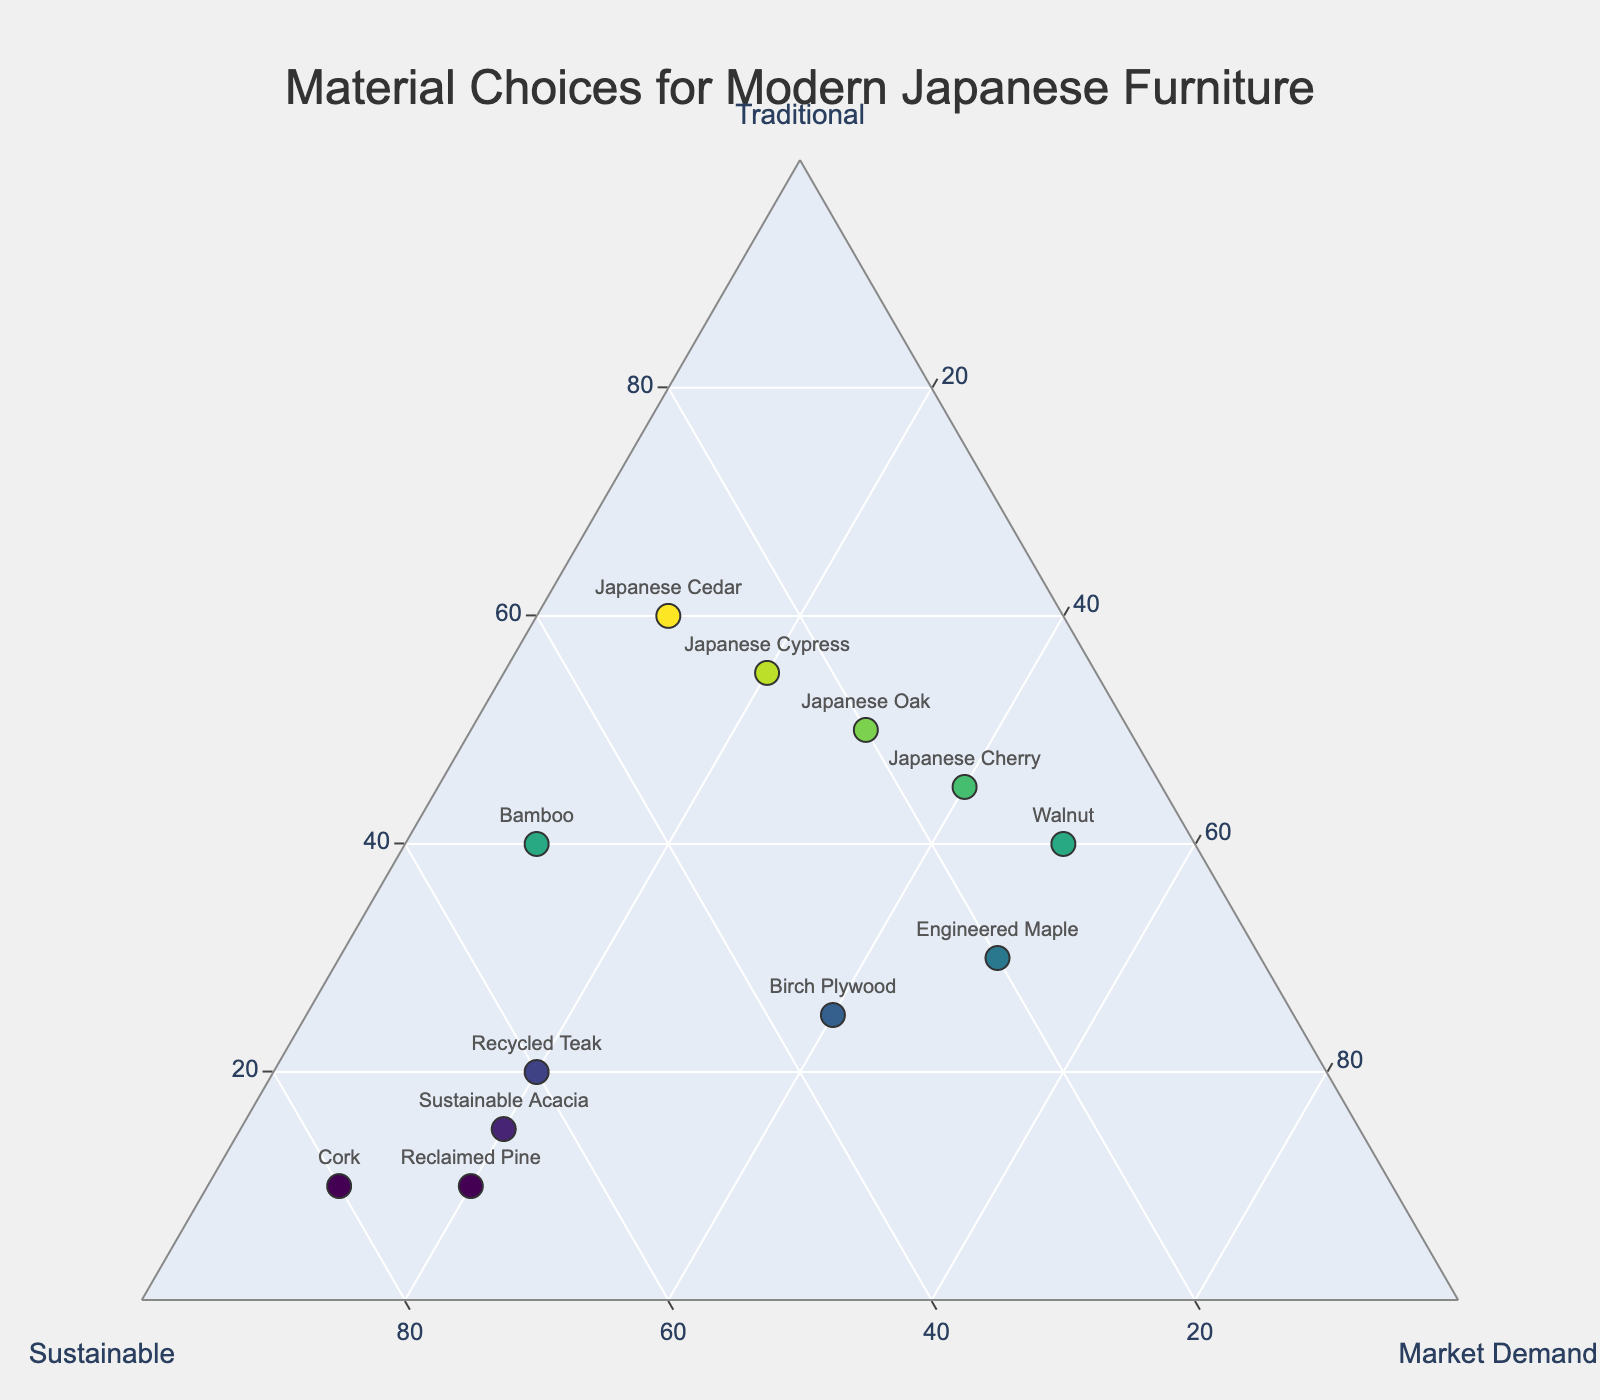How many materials are plotted on the ternary plot? Count the number of data points or markers on the plot.
Answer: 12 What is the title of the ternary plot? Look at the title text positioned above the ternary plot.
Answer: Material Choices for Modern Japanese Furniture Which material has the highest sustainability percentage? Identify the point closest to the "Sustainable" vertex (higher b-axis value). Hover over the data points to check sustainability percentages.
Answer: Cork Which material is closest to equally balancing tradition, sustainability, and market demand? Look for the point closest to the center of the ternary plot where all three axes intersect.
Answer: Birch Plywood Among Japanese Cherry and Japanese Cedar, which one has a higher market demand percentage? Compare the positions of these materials along the "Market Demand" axis (c-axis) by checking their hover details.
Answer: Japanese Cherry What is the total percentage of traditional, sustainable, and market demand for Japanese Cypress? Add the percentages for traditional, sustainable, and market demand for Japanese Cypress from the hover details.
Answer: 100% Is there any material that has exactly the same percentage values for traditional and market demand? Check the hover details for each data point to see if any material has equal values for traditional and market demand.
Answer: No Which material shows the lowest traditional value and is also highly sustainable? Identify the material with the smallest traditional value and a high b-axis value.
Answer: Cork Among the materials with market demand over 40%, which one has the highest traditional value? Filter out materials with market demand > 40% and compare their traditional values.
Answer: Japanese Cherry What general trend can be observed between sustainability and tradition for Japanese woods? When comparing Japanese woods, observe if there's an inverse relationship between sustainability and tradition percentages.
Answer: Higher tradition, lower sustainability 